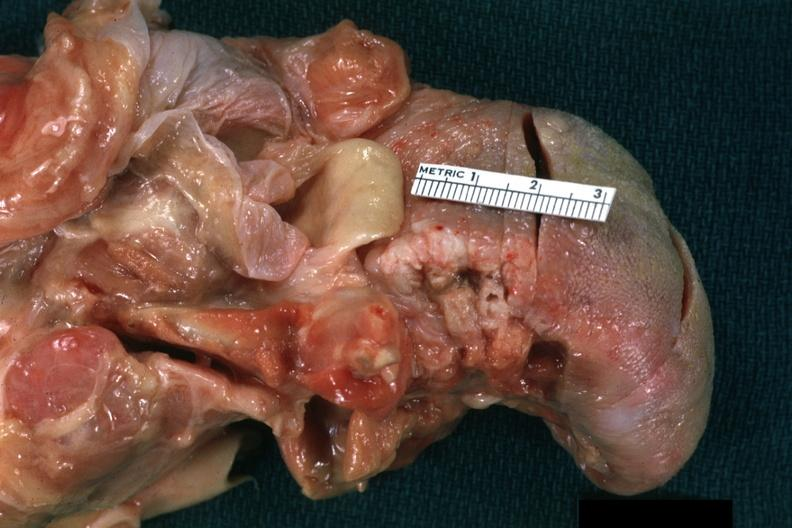what is present?
Answer the question using a single word or phrase. Tongue 